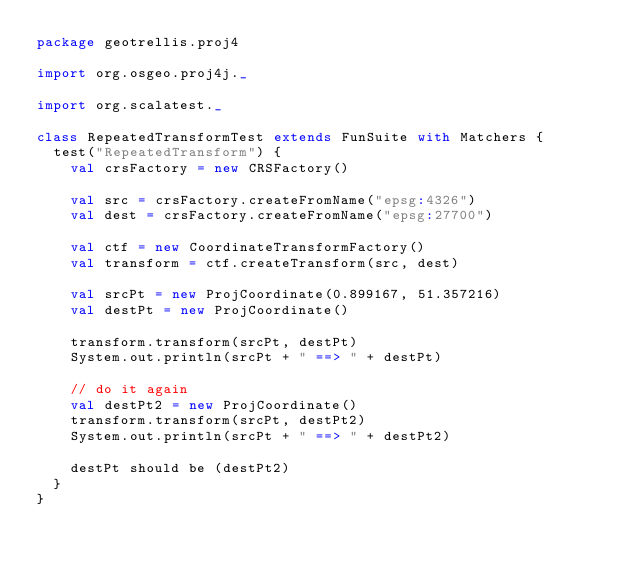<code> <loc_0><loc_0><loc_500><loc_500><_Scala_>package geotrellis.proj4

import org.osgeo.proj4j._

import org.scalatest._

class RepeatedTransformTest extends FunSuite with Matchers {
  test("RepeatedTransform") {
    val crsFactory = new CRSFactory()

    val src = crsFactory.createFromName("epsg:4326")
    val dest = crsFactory.createFromName("epsg:27700")

    val ctf = new CoordinateTransformFactory()
    val transform = ctf.createTransform(src, dest)
    
    val srcPt = new ProjCoordinate(0.899167, 51.357216)
    val destPt = new ProjCoordinate()
   
    transform.transform(srcPt, destPt)
    System.out.println(srcPt + " ==> " + destPt)
    
    // do it again
    val destPt2 = new ProjCoordinate()
    transform.transform(srcPt, destPt2)
    System.out.println(srcPt + " ==> " + destPt2)

    destPt should be (destPt2)
  }
}
</code> 